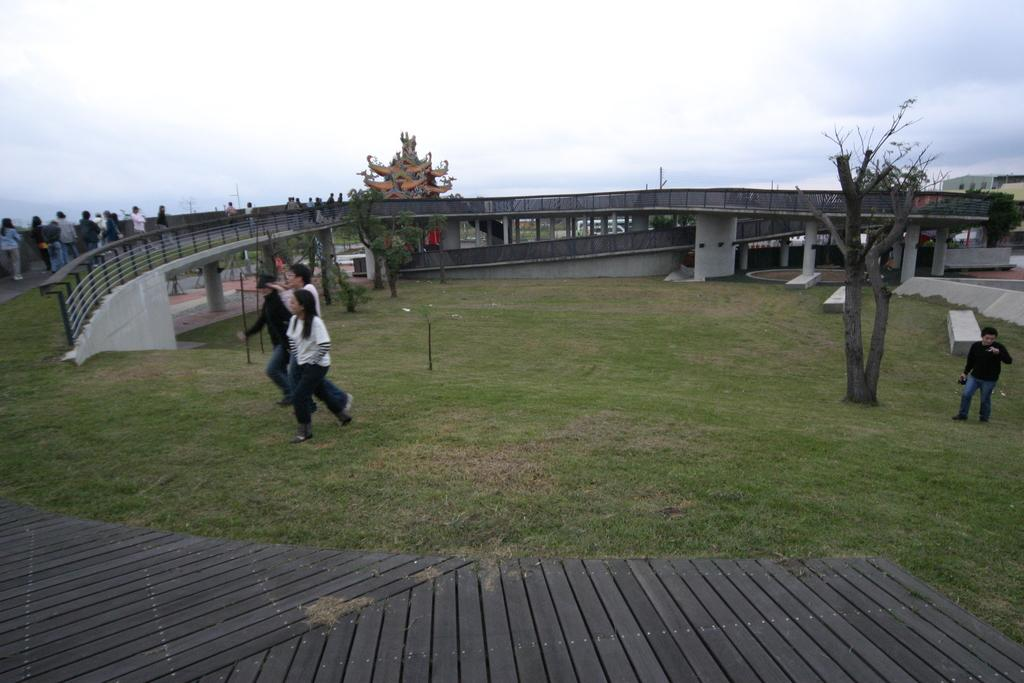What are the people in the image doing? The persons standing on the ground in the image are likely standing or observing something. What type of natural elements can be seen in the image? There are trees in the image. What architectural feature is visible in the image? Railings are visible in the image. What is visible in the background of the image? The sky is visible in the image, and clouds are present in the sky. What type of crown is being advertised on the railings in the image? There is no crown or advertisement present in the image; it only features persons standing on the ground, trees, railings, and the sky. 